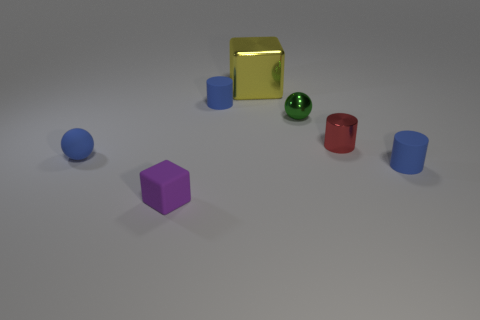Subtract all small blue cylinders. How many cylinders are left? 1 Subtract all blue cylinders. How many cylinders are left? 1 Subtract 1 balls. How many balls are left? 1 Add 3 gray metallic cubes. How many objects exist? 10 Subtract all cylinders. How many objects are left? 4 Subtract 1 red cylinders. How many objects are left? 6 Subtract all green cylinders. Subtract all green blocks. How many cylinders are left? 3 Subtract all green cylinders. How many yellow blocks are left? 1 Subtract all red cylinders. Subtract all small blue cylinders. How many objects are left? 4 Add 5 green metallic things. How many green metallic things are left? 6 